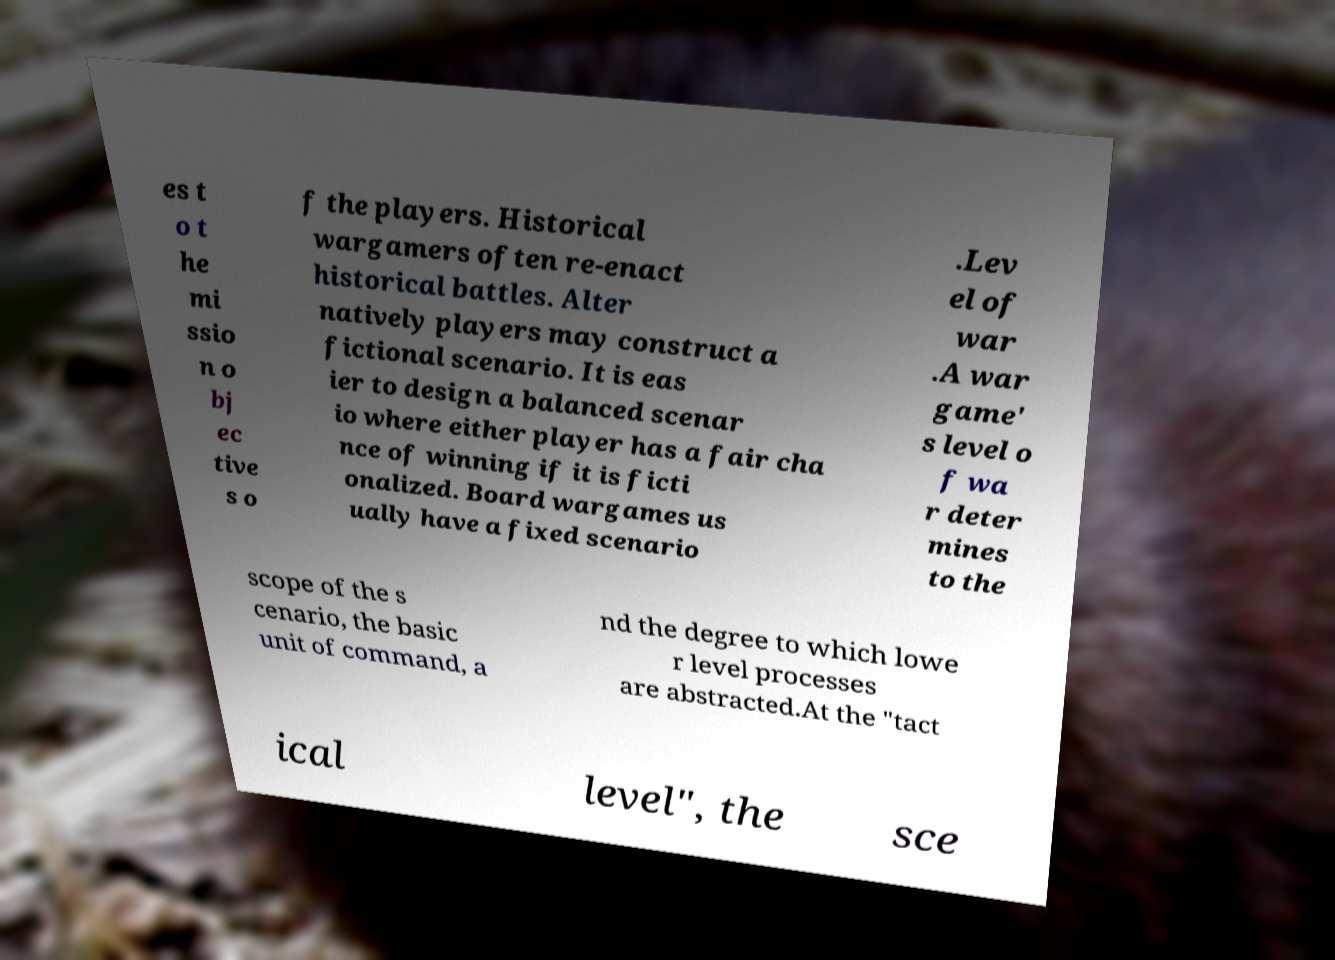Could you extract and type out the text from this image? es t o t he mi ssio n o bj ec tive s o f the players. Historical wargamers often re-enact historical battles. Alter natively players may construct a fictional scenario. It is eas ier to design a balanced scenar io where either player has a fair cha nce of winning if it is ficti onalized. Board wargames us ually have a fixed scenario .Lev el of war .A war game' s level o f wa r deter mines to the scope of the s cenario, the basic unit of command, a nd the degree to which lowe r level processes are abstracted.At the "tact ical level", the sce 